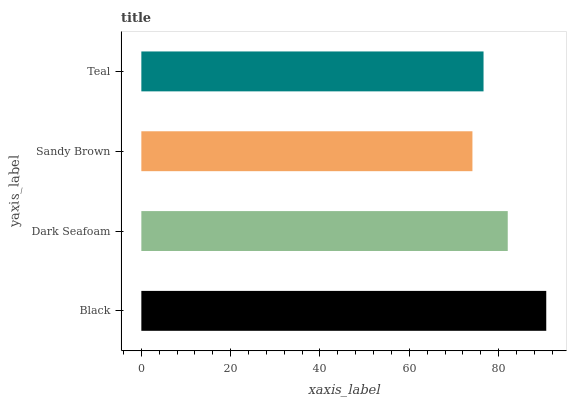Is Sandy Brown the minimum?
Answer yes or no. Yes. Is Black the maximum?
Answer yes or no. Yes. Is Dark Seafoam the minimum?
Answer yes or no. No. Is Dark Seafoam the maximum?
Answer yes or no. No. Is Black greater than Dark Seafoam?
Answer yes or no. Yes. Is Dark Seafoam less than Black?
Answer yes or no. Yes. Is Dark Seafoam greater than Black?
Answer yes or no. No. Is Black less than Dark Seafoam?
Answer yes or no. No. Is Dark Seafoam the high median?
Answer yes or no. Yes. Is Teal the low median?
Answer yes or no. Yes. Is Teal the high median?
Answer yes or no. No. Is Sandy Brown the low median?
Answer yes or no. No. 